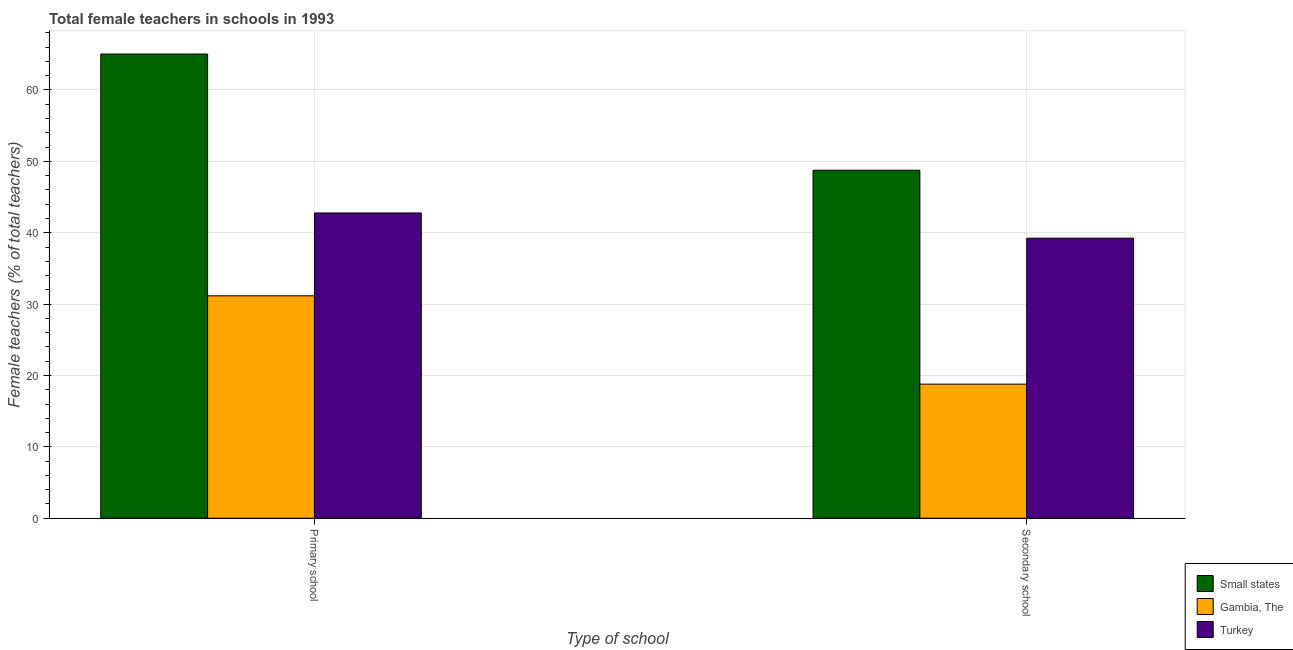How many groups of bars are there?
Provide a succinct answer. 2. Are the number of bars per tick equal to the number of legend labels?
Keep it short and to the point. Yes. How many bars are there on the 1st tick from the right?
Your answer should be compact. 3. What is the label of the 2nd group of bars from the left?
Offer a terse response. Secondary school. What is the percentage of female teachers in secondary schools in Small states?
Your answer should be very brief. 48.76. Across all countries, what is the maximum percentage of female teachers in primary schools?
Provide a succinct answer. 65.04. Across all countries, what is the minimum percentage of female teachers in secondary schools?
Provide a short and direct response. 18.79. In which country was the percentage of female teachers in secondary schools maximum?
Your answer should be compact. Small states. In which country was the percentage of female teachers in primary schools minimum?
Give a very brief answer. Gambia, The. What is the total percentage of female teachers in secondary schools in the graph?
Provide a succinct answer. 106.78. What is the difference between the percentage of female teachers in secondary schools in Turkey and that in Gambia, The?
Provide a short and direct response. 20.45. What is the difference between the percentage of female teachers in primary schools in Small states and the percentage of female teachers in secondary schools in Turkey?
Your response must be concise. 25.8. What is the average percentage of female teachers in primary schools per country?
Provide a succinct answer. 46.32. What is the difference between the percentage of female teachers in primary schools and percentage of female teachers in secondary schools in Gambia, The?
Your answer should be compact. 12.38. In how many countries, is the percentage of female teachers in primary schools greater than 44 %?
Ensure brevity in your answer.  1. What is the ratio of the percentage of female teachers in primary schools in Gambia, The to that in Small states?
Ensure brevity in your answer.  0.48. Is the percentage of female teachers in secondary schools in Small states less than that in Turkey?
Your answer should be very brief. No. In how many countries, is the percentage of female teachers in primary schools greater than the average percentage of female teachers in primary schools taken over all countries?
Keep it short and to the point. 1. What does the 3rd bar from the right in Secondary school represents?
Provide a short and direct response. Small states. What is the difference between two consecutive major ticks on the Y-axis?
Your answer should be very brief. 10. Does the graph contain grids?
Keep it short and to the point. Yes. How many legend labels are there?
Make the answer very short. 3. How are the legend labels stacked?
Offer a terse response. Vertical. What is the title of the graph?
Provide a succinct answer. Total female teachers in schools in 1993. What is the label or title of the X-axis?
Your response must be concise. Type of school. What is the label or title of the Y-axis?
Your answer should be compact. Female teachers (% of total teachers). What is the Female teachers (% of total teachers) of Small states in Primary school?
Provide a short and direct response. 65.04. What is the Female teachers (% of total teachers) in Gambia, The in Primary school?
Your response must be concise. 31.16. What is the Female teachers (% of total teachers) in Turkey in Primary school?
Your answer should be very brief. 42.77. What is the Female teachers (% of total teachers) of Small states in Secondary school?
Your answer should be compact. 48.76. What is the Female teachers (% of total teachers) of Gambia, The in Secondary school?
Your answer should be very brief. 18.79. What is the Female teachers (% of total teachers) in Turkey in Secondary school?
Offer a very short reply. 39.24. Across all Type of school, what is the maximum Female teachers (% of total teachers) of Small states?
Your response must be concise. 65.04. Across all Type of school, what is the maximum Female teachers (% of total teachers) of Gambia, The?
Keep it short and to the point. 31.16. Across all Type of school, what is the maximum Female teachers (% of total teachers) in Turkey?
Your answer should be compact. 42.77. Across all Type of school, what is the minimum Female teachers (% of total teachers) of Small states?
Provide a short and direct response. 48.76. Across all Type of school, what is the minimum Female teachers (% of total teachers) of Gambia, The?
Your response must be concise. 18.79. Across all Type of school, what is the minimum Female teachers (% of total teachers) of Turkey?
Offer a very short reply. 39.24. What is the total Female teachers (% of total teachers) of Small states in the graph?
Your response must be concise. 113.8. What is the total Female teachers (% of total teachers) of Gambia, The in the graph?
Keep it short and to the point. 49.95. What is the total Female teachers (% of total teachers) of Turkey in the graph?
Keep it short and to the point. 82.01. What is the difference between the Female teachers (% of total teachers) in Small states in Primary school and that in Secondary school?
Offer a very short reply. 16.28. What is the difference between the Female teachers (% of total teachers) of Gambia, The in Primary school and that in Secondary school?
Your response must be concise. 12.38. What is the difference between the Female teachers (% of total teachers) in Turkey in Primary school and that in Secondary school?
Offer a terse response. 3.54. What is the difference between the Female teachers (% of total teachers) in Small states in Primary school and the Female teachers (% of total teachers) in Gambia, The in Secondary school?
Offer a very short reply. 46.25. What is the difference between the Female teachers (% of total teachers) in Small states in Primary school and the Female teachers (% of total teachers) in Turkey in Secondary school?
Ensure brevity in your answer.  25.8. What is the difference between the Female teachers (% of total teachers) of Gambia, The in Primary school and the Female teachers (% of total teachers) of Turkey in Secondary school?
Keep it short and to the point. -8.07. What is the average Female teachers (% of total teachers) of Small states per Type of school?
Provide a short and direct response. 56.9. What is the average Female teachers (% of total teachers) of Gambia, The per Type of school?
Your response must be concise. 24.97. What is the average Female teachers (% of total teachers) in Turkey per Type of school?
Provide a succinct answer. 41. What is the difference between the Female teachers (% of total teachers) of Small states and Female teachers (% of total teachers) of Gambia, The in Primary school?
Your response must be concise. 33.88. What is the difference between the Female teachers (% of total teachers) of Small states and Female teachers (% of total teachers) of Turkey in Primary school?
Offer a terse response. 22.27. What is the difference between the Female teachers (% of total teachers) of Gambia, The and Female teachers (% of total teachers) of Turkey in Primary school?
Provide a succinct answer. -11.61. What is the difference between the Female teachers (% of total teachers) in Small states and Female teachers (% of total teachers) in Gambia, The in Secondary school?
Your answer should be compact. 29.97. What is the difference between the Female teachers (% of total teachers) in Small states and Female teachers (% of total teachers) in Turkey in Secondary school?
Provide a short and direct response. 9.52. What is the difference between the Female teachers (% of total teachers) in Gambia, The and Female teachers (% of total teachers) in Turkey in Secondary school?
Provide a succinct answer. -20.45. What is the ratio of the Female teachers (% of total teachers) of Small states in Primary school to that in Secondary school?
Your answer should be compact. 1.33. What is the ratio of the Female teachers (% of total teachers) of Gambia, The in Primary school to that in Secondary school?
Ensure brevity in your answer.  1.66. What is the ratio of the Female teachers (% of total teachers) of Turkey in Primary school to that in Secondary school?
Provide a succinct answer. 1.09. What is the difference between the highest and the second highest Female teachers (% of total teachers) in Small states?
Keep it short and to the point. 16.28. What is the difference between the highest and the second highest Female teachers (% of total teachers) in Gambia, The?
Give a very brief answer. 12.38. What is the difference between the highest and the second highest Female teachers (% of total teachers) in Turkey?
Your response must be concise. 3.54. What is the difference between the highest and the lowest Female teachers (% of total teachers) in Small states?
Your response must be concise. 16.28. What is the difference between the highest and the lowest Female teachers (% of total teachers) in Gambia, The?
Provide a succinct answer. 12.38. What is the difference between the highest and the lowest Female teachers (% of total teachers) of Turkey?
Your response must be concise. 3.54. 